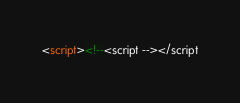<code> <loc_0><loc_0><loc_500><loc_500><_HTML_><script><!--<script --></script
</code> 